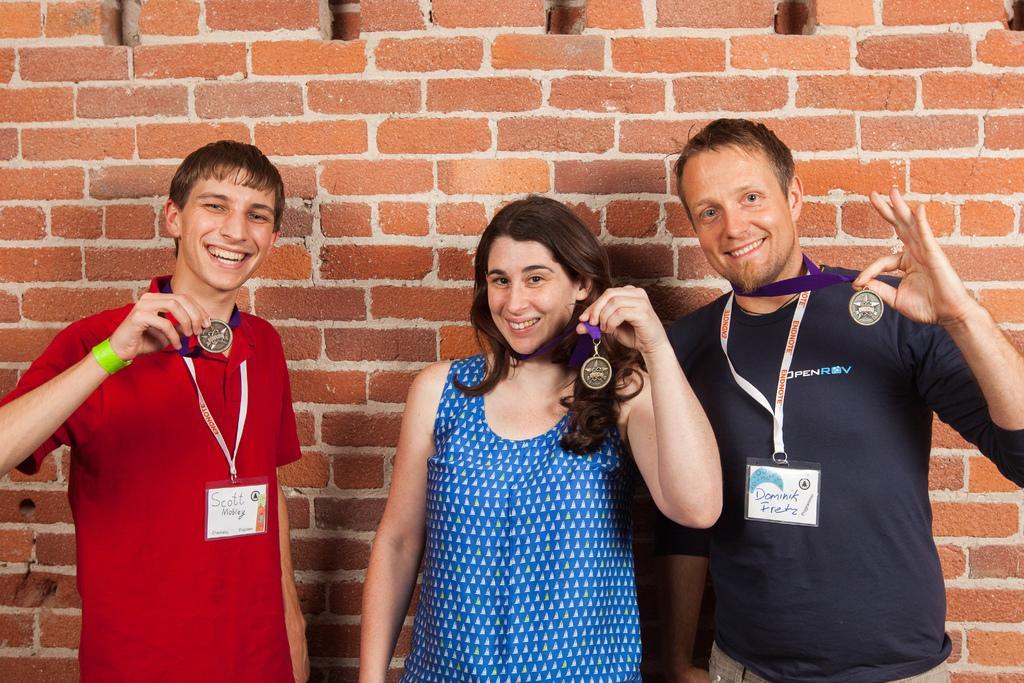Describe this image in one or two sentences. In this image we can see there are three people showing their medals and posing for a picture, behind them there is a brick wall. 